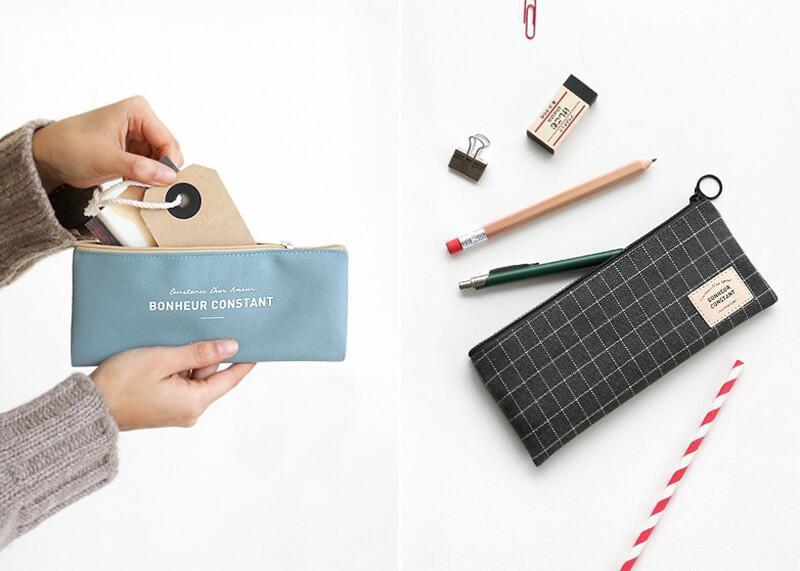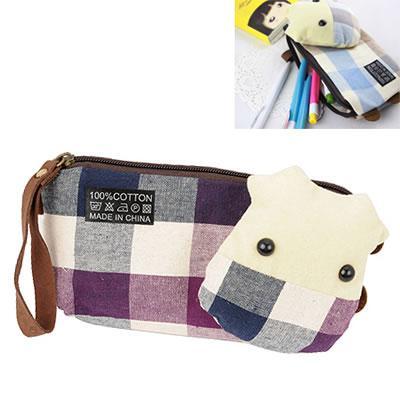The first image is the image on the left, the second image is the image on the right. Evaluate the accuracy of this statement regarding the images: "The left image shows a pair of hands holding a zipper case featuring light-blue color and its contents.". Is it true? Answer yes or no. Yes. 